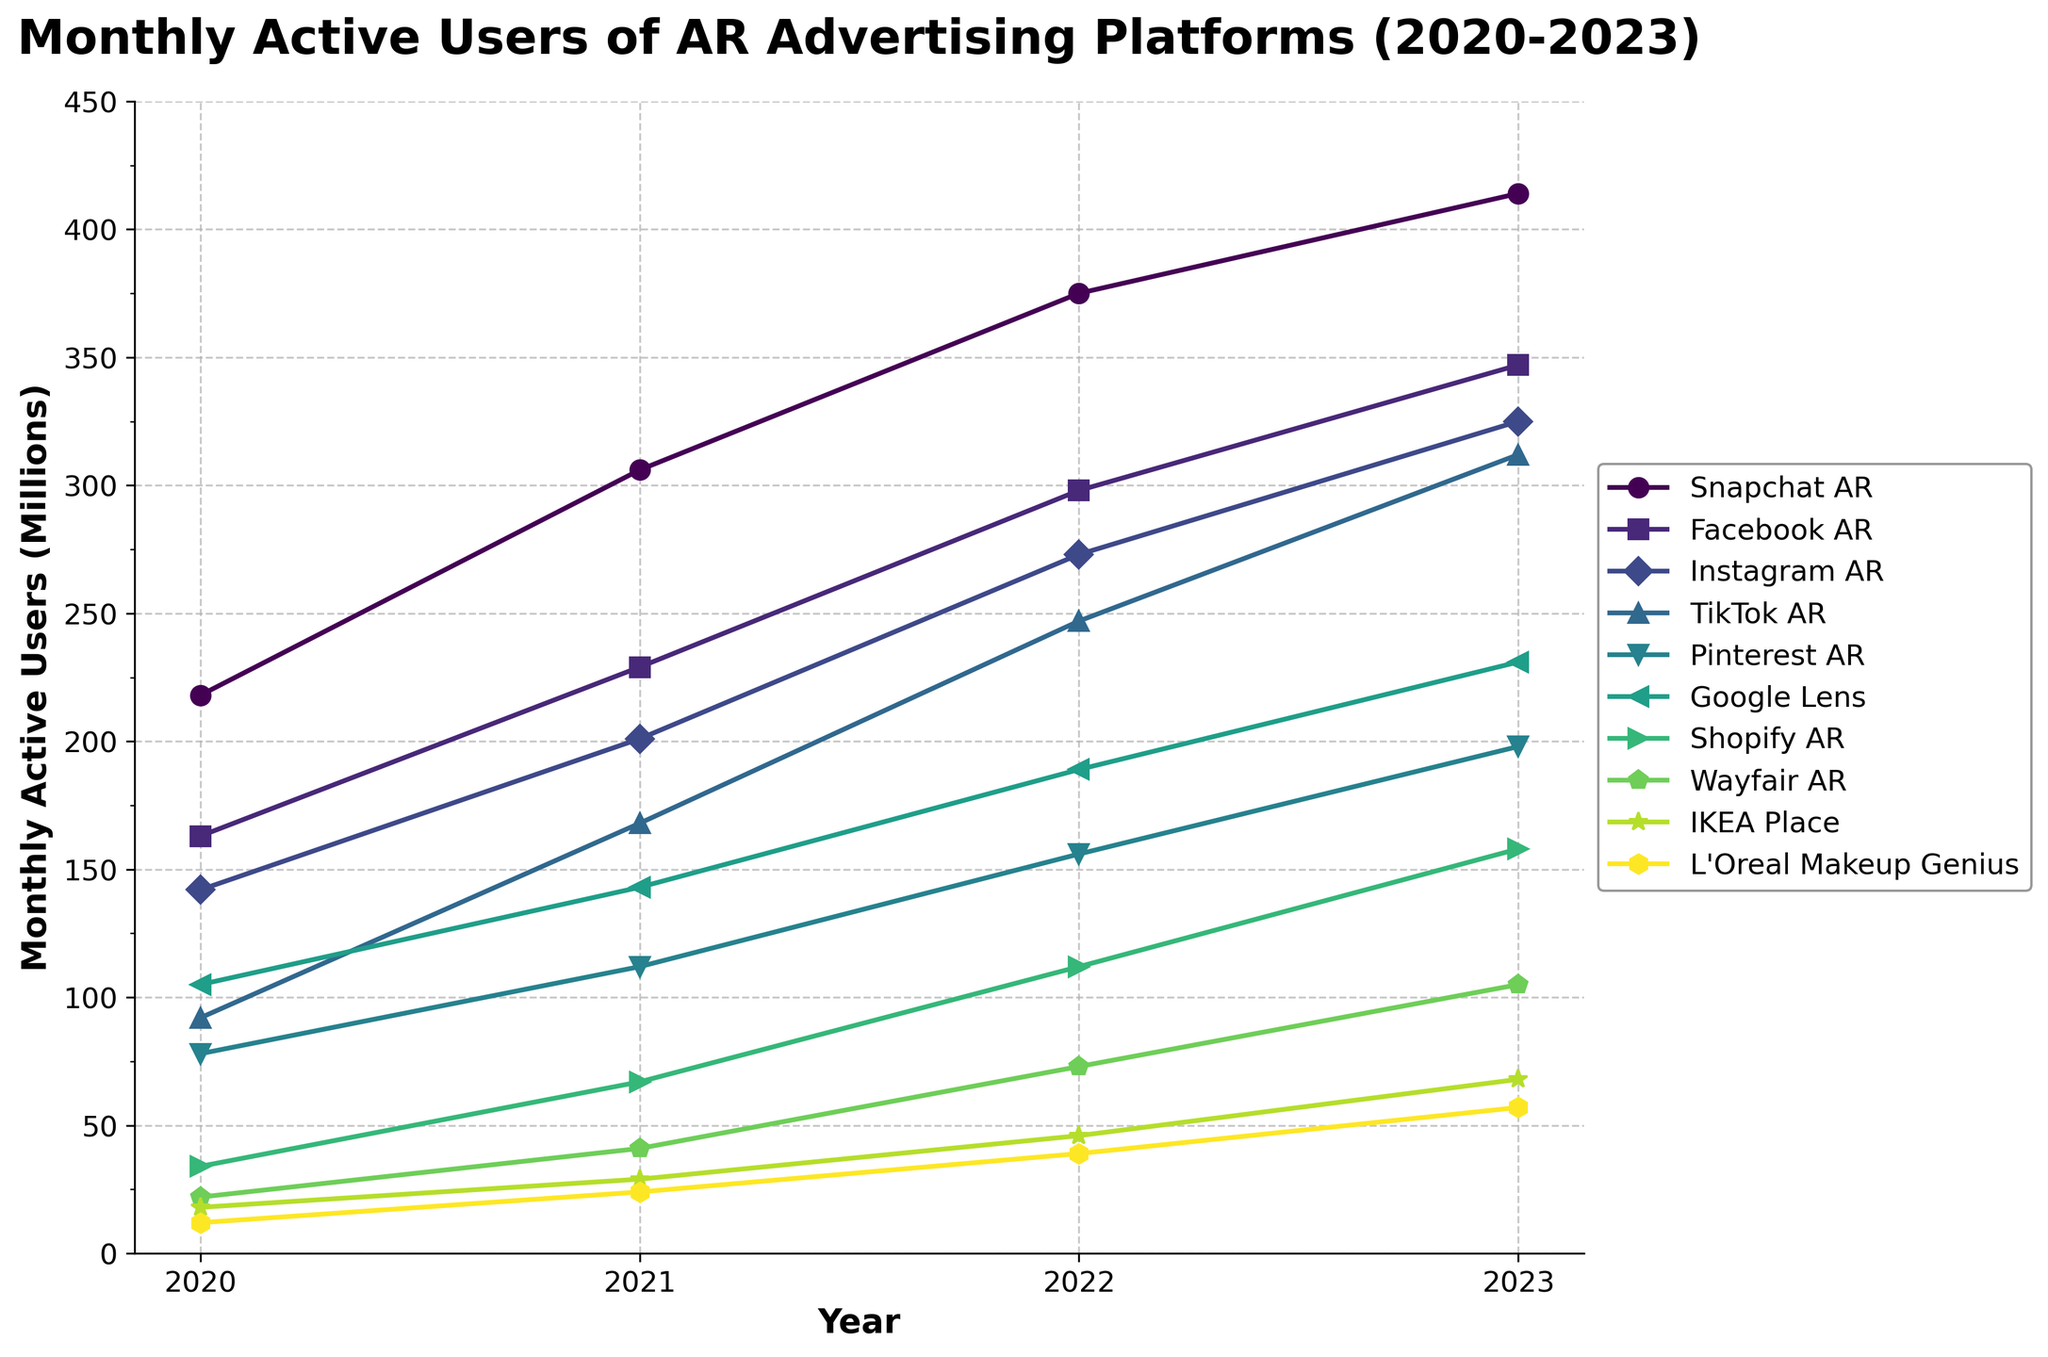Which AR advertising platform had the highest monthly active users in 2023? Examine the line chart and identify which platform's line reaches the highest point in 2023. The line for Snapchat AR reaches the highest at 414 million users.
Answer: Snapchat AR Which AR advertising platform showed the largest growth in monthly active users from 2020 to 2023? Compare the growth (2023 value - 2020 value) for each platform. Snapchat AR grew by 196 million (414 - 218), which is the largest growth among all platforms.
Answer: Snapchat AR Which two platforms had almost equal monthly active users in 2022? Look at the values for 2022 in the chart and find two platforms with similar values. Facebook AR and Instagram AR both had 273 and 298 million users, which are quite close.
Answer: Instagram AR and Facebook AR What is the average number of monthly active users for Pinterest AR from 2020 to 2023? Sum the number of monthly active users from 2020 to 2023 for Pinterest AR and divide by 4. (78 + 112 + 156 + 198) / 4 = 136.
Answer: 136 Which platform saw the least increase in monthly active users from 2020 to 2023? Calculate the increase (2023 value - 2020 value) for each platform. L'Oreal Makeup Genius increased from 12 to 57, which is only 45 million, the least among the platforms.
Answer: L'Oreal Makeup Genius How does the growth rate of TikTok AR compare to that of Google Lens between 2020 and 2023? Calculate the growth (2023 value - 2020 value) for both platforms. TikTok AR: 312 - 92 = 220; Google Lens: 231 - 105 = 126. TikTok AR's growth is higher.
Answer: TikTok AR has a higher growth rate Which platform had the biggest jump in users between any two consecutive years? Look at the year-over-year increments and identify the largest one. TikTok AR grew by 76 million from 2021 to 2022 (168 to 247), which is the largest jump.
Answer: TikTok AR from 2021 to 2022 What is the combined number of monthly active users for the three least popular platforms in 2023? Identify the three platforms with the lowest user numbers in 2023, and sum their values: IKEA Place, Wayfair AR, and L'Oreal Makeup Genius (68 + 105 + 57). Combined, that's 230 million.
Answer: 230 Which year did Instagram AR first surpass 200 million monthly active users? Check the values for Instagram AR across the years and see where it first exceeds 200. In 2021, Instagram AR reached 201 million.
Answer: 2021 In which year did Snapchat AR see its fastest growth in terms of absolute user numbers? Compare year-over-year growth for Snapchat AR and identify the largest increment. The growth from 2020 to 2021 is 88 million (306 - 218), the highest among the years.
Answer: 2020 to 2021 